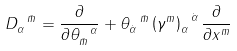Convert formula to latex. <formula><loc_0><loc_0><loc_500><loc_500>D _ { \alpha } ^ { \ \bar { m } } = \frac { \partial } { \partial \theta _ { \bar { m } } ^ { \ \alpha } } + \theta _ { \dot { \alpha } } ^ { \ \bar { m } } \left ( \gamma ^ { m } \right ) _ { \alpha } ^ { \ \dot { \alpha } } \frac { \partial } { \partial x ^ { m } }</formula> 